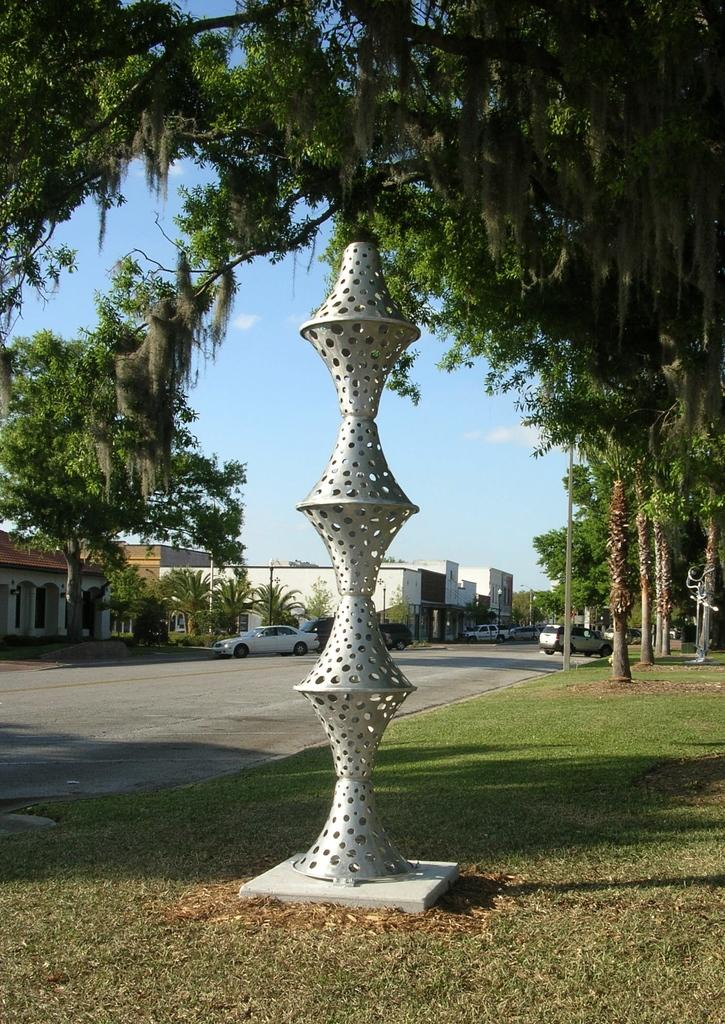What type of structures can be seen in the image? There are buildings in the image. What other natural elements are present in the image? There are trees in the image. What man-made objects can be seen in the image? There are vehicles and poles in the image. Can you describe the color of one of the poles in the image? There is an ash-colored pole in the image. What is the color of the sky in the image? The sky is blue and white in color. Where is the drawer located in the image? There is no drawer present in the image. Can you describe the snails crawling on the buildings in the image? There are no snails present in the image; it only features buildings, trees, vehicles, poles, and a sky. 